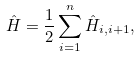<formula> <loc_0><loc_0><loc_500><loc_500>\hat { H } = { \frac { 1 } { 2 } } \sum _ { i = 1 } ^ { n } \hat { H } _ { i , i + 1 } ,</formula> 